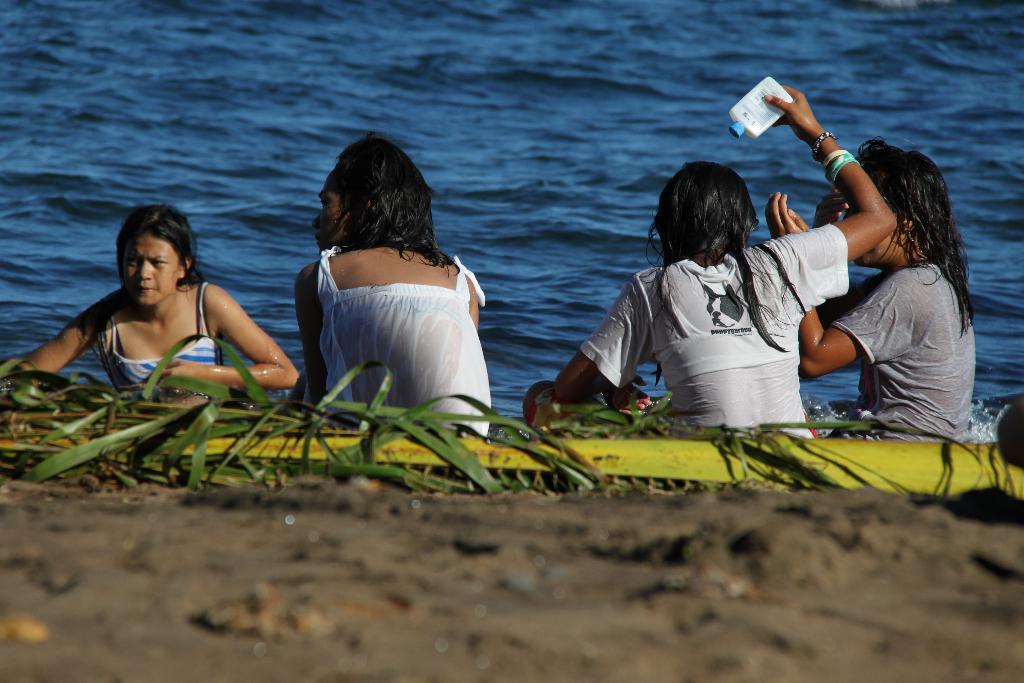Can you describe this image briefly? In this picture we can see 4 girls sitting on the bank of a river and looking at someone. The water is blue. 